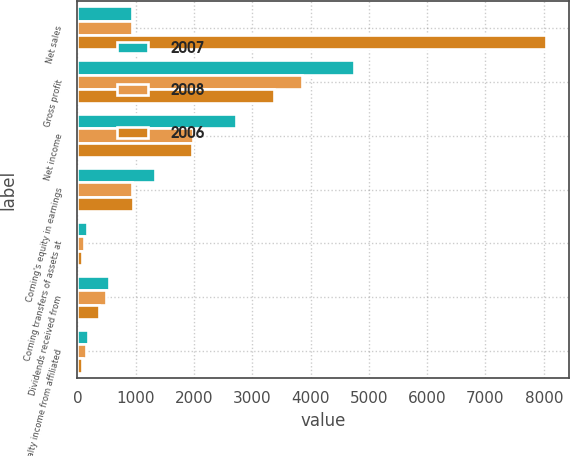Convert chart to OTSL. <chart><loc_0><loc_0><loc_500><loc_500><stacked_bar_chart><ecel><fcel>Net sales<fcel>Gross profit<fcel>Net income<fcel>Corning's equity in earnings<fcel>Corning transfers of assets at<fcel>Dividends received from<fcel>Royalty income from affiliated<nl><fcel>2007<fcel>942<fcel>4752<fcel>2724<fcel>1328<fcel>173<fcel>546<fcel>188<nl><fcel>2008<fcel>942<fcel>3852<fcel>1978<fcel>942<fcel>110<fcel>490<fcel>149<nl><fcel>2006<fcel>8039<fcel>3368<fcel>1968<fcel>960<fcel>71<fcel>363<fcel>88<nl></chart> 